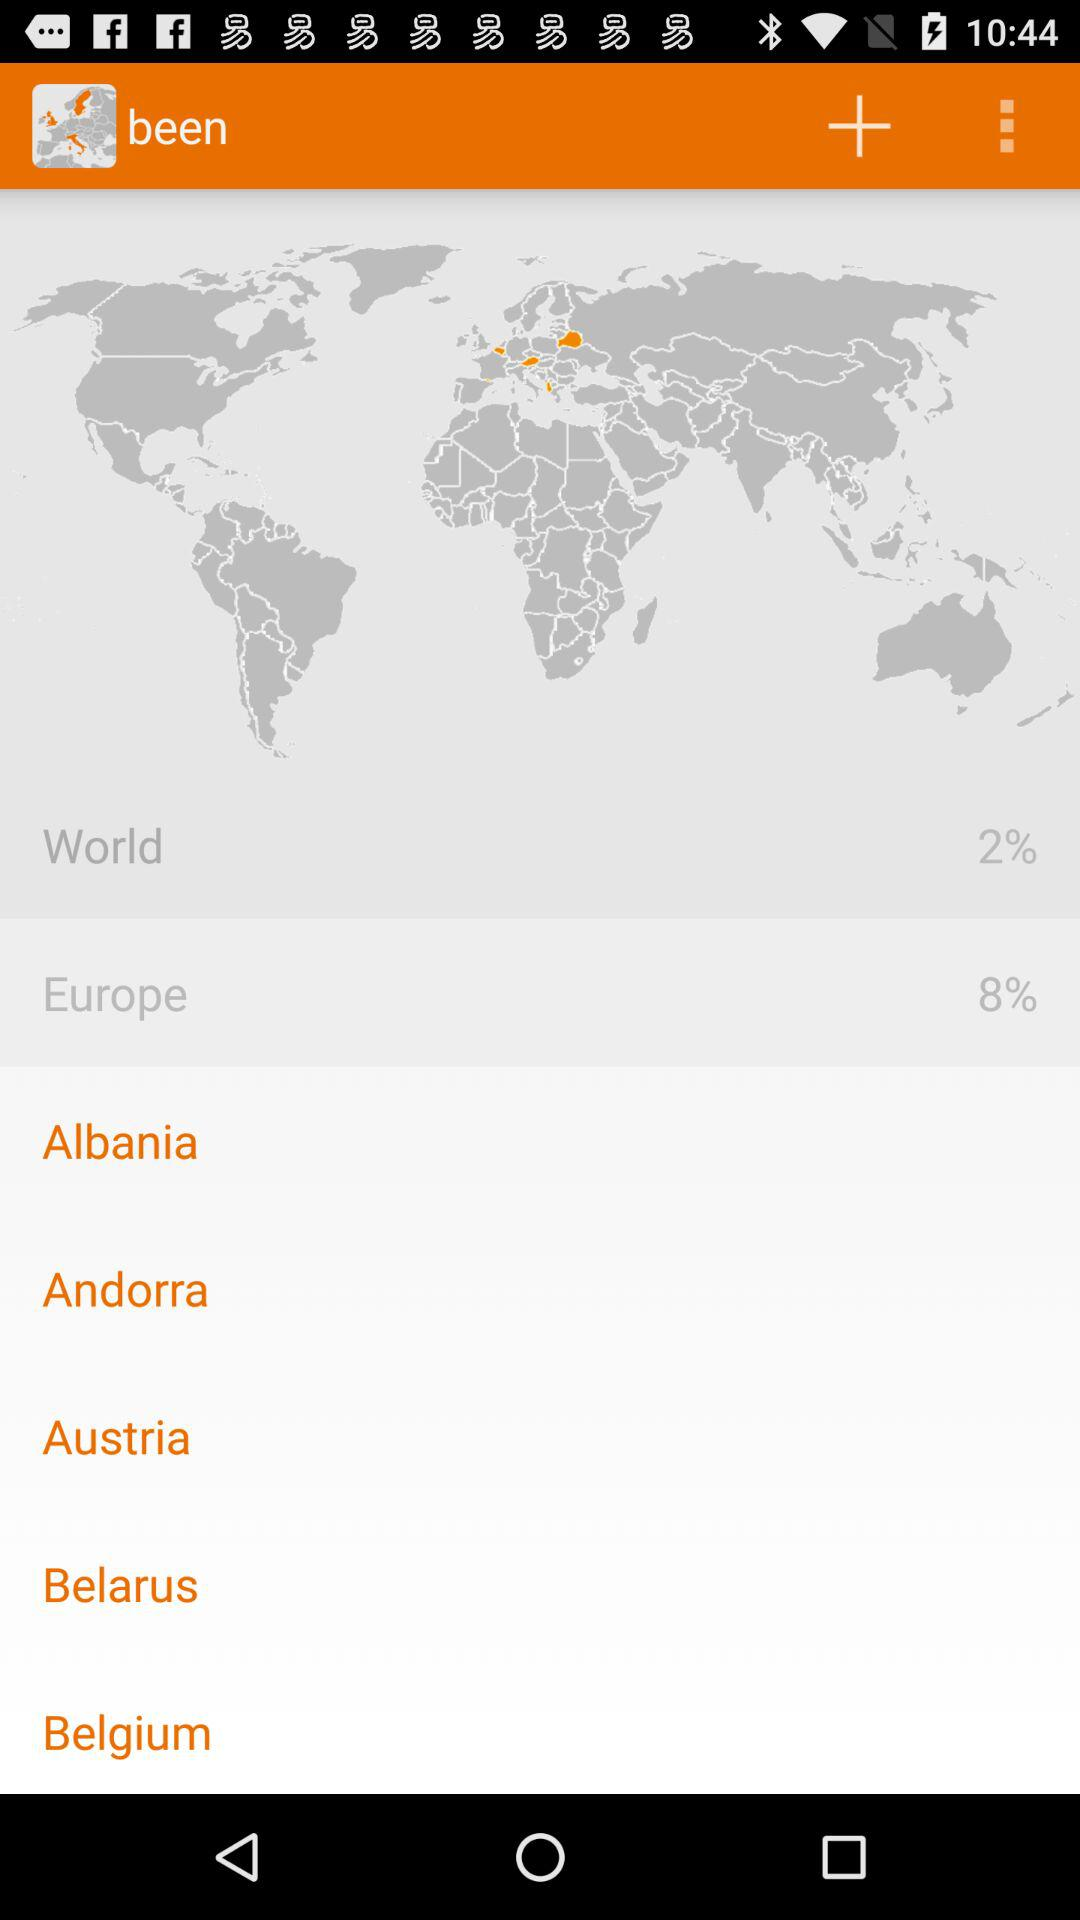What is the name of the application? The application name is "been". 